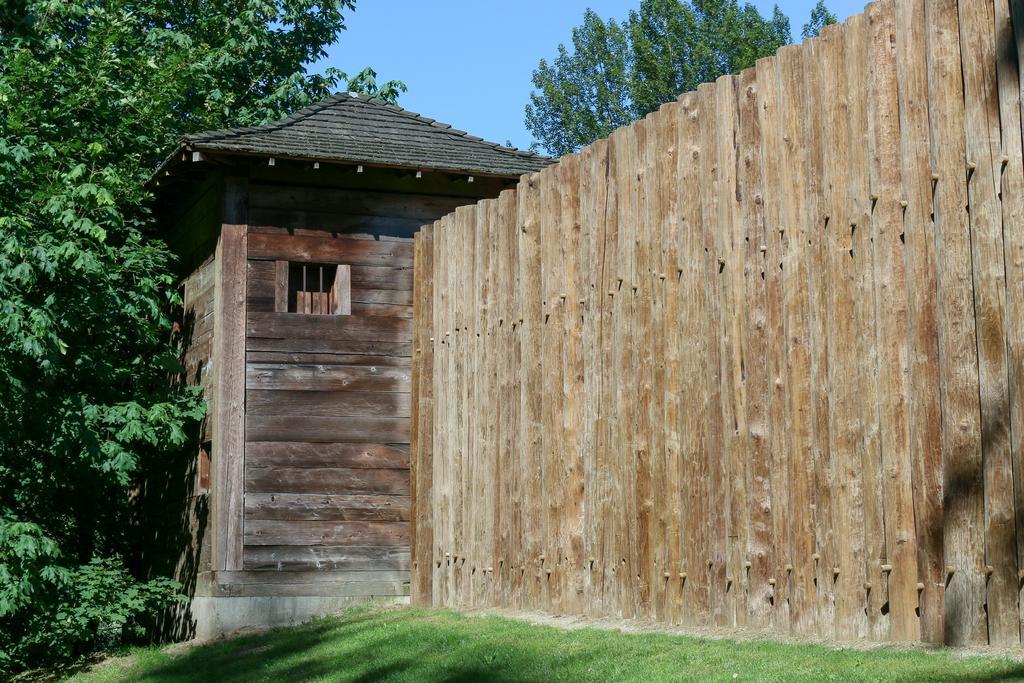Please provide a concise description of this image. In this image in the center there is one hut, and on the right side of the image there are some wooden sticks. At the bottom there is grass and in the background there are trees, at the top there is sky. 